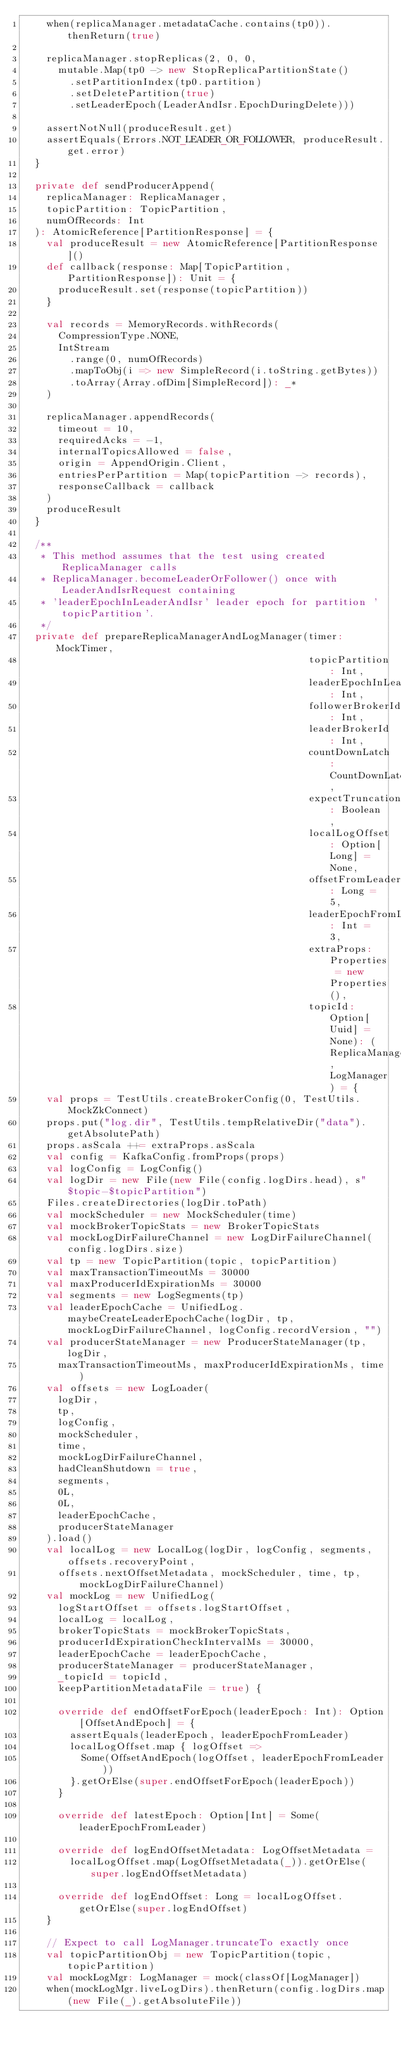Convert code to text. <code><loc_0><loc_0><loc_500><loc_500><_Scala_>    when(replicaManager.metadataCache.contains(tp0)).thenReturn(true)

    replicaManager.stopReplicas(2, 0, 0,
      mutable.Map(tp0 -> new StopReplicaPartitionState()
        .setPartitionIndex(tp0.partition)
        .setDeletePartition(true)
        .setLeaderEpoch(LeaderAndIsr.EpochDuringDelete)))

    assertNotNull(produceResult.get)
    assertEquals(Errors.NOT_LEADER_OR_FOLLOWER, produceResult.get.error)
  }

  private def sendProducerAppend(
    replicaManager: ReplicaManager,
    topicPartition: TopicPartition,
    numOfRecords: Int
  ): AtomicReference[PartitionResponse] = {
    val produceResult = new AtomicReference[PartitionResponse]()
    def callback(response: Map[TopicPartition, PartitionResponse]): Unit = {
      produceResult.set(response(topicPartition))
    }

    val records = MemoryRecords.withRecords(
      CompressionType.NONE,
      IntStream
        .range(0, numOfRecords)
        .mapToObj(i => new SimpleRecord(i.toString.getBytes))
        .toArray(Array.ofDim[SimpleRecord]): _*
    )

    replicaManager.appendRecords(
      timeout = 10,
      requiredAcks = -1,
      internalTopicsAllowed = false,
      origin = AppendOrigin.Client,
      entriesPerPartition = Map(topicPartition -> records),
      responseCallback = callback
    )
    produceResult
  }

  /**
   * This method assumes that the test using created ReplicaManager calls
   * ReplicaManager.becomeLeaderOrFollower() once with LeaderAndIsrRequest containing
   * 'leaderEpochInLeaderAndIsr' leader epoch for partition 'topicPartition'.
   */
  private def prepareReplicaManagerAndLogManager(timer: MockTimer,
                                                 topicPartition: Int,
                                                 leaderEpochInLeaderAndIsr: Int,
                                                 followerBrokerId: Int,
                                                 leaderBrokerId: Int,
                                                 countDownLatch: CountDownLatch,
                                                 expectTruncation: Boolean,
                                                 localLogOffset: Option[Long] = None,
                                                 offsetFromLeader: Long = 5,
                                                 leaderEpochFromLeader: Int = 3,
                                                 extraProps: Properties = new Properties(),
                                                 topicId: Option[Uuid] = None): (ReplicaManager, LogManager) = {
    val props = TestUtils.createBrokerConfig(0, TestUtils.MockZkConnect)
    props.put("log.dir", TestUtils.tempRelativeDir("data").getAbsolutePath)
    props.asScala ++= extraProps.asScala
    val config = KafkaConfig.fromProps(props)
    val logConfig = LogConfig()
    val logDir = new File(new File(config.logDirs.head), s"$topic-$topicPartition")
    Files.createDirectories(logDir.toPath)
    val mockScheduler = new MockScheduler(time)
    val mockBrokerTopicStats = new BrokerTopicStats
    val mockLogDirFailureChannel = new LogDirFailureChannel(config.logDirs.size)
    val tp = new TopicPartition(topic, topicPartition)
    val maxTransactionTimeoutMs = 30000
    val maxProducerIdExpirationMs = 30000
    val segments = new LogSegments(tp)
    val leaderEpochCache = UnifiedLog.maybeCreateLeaderEpochCache(logDir, tp, mockLogDirFailureChannel, logConfig.recordVersion, "")
    val producerStateManager = new ProducerStateManager(tp, logDir,
      maxTransactionTimeoutMs, maxProducerIdExpirationMs, time)
    val offsets = new LogLoader(
      logDir,
      tp,
      logConfig,
      mockScheduler,
      time,
      mockLogDirFailureChannel,
      hadCleanShutdown = true,
      segments,
      0L,
      0L,
      leaderEpochCache,
      producerStateManager
    ).load()
    val localLog = new LocalLog(logDir, logConfig, segments, offsets.recoveryPoint,
      offsets.nextOffsetMetadata, mockScheduler, time, tp, mockLogDirFailureChannel)
    val mockLog = new UnifiedLog(
      logStartOffset = offsets.logStartOffset,
      localLog = localLog,
      brokerTopicStats = mockBrokerTopicStats,
      producerIdExpirationCheckIntervalMs = 30000,
      leaderEpochCache = leaderEpochCache,
      producerStateManager = producerStateManager,
      _topicId = topicId,
      keepPartitionMetadataFile = true) {

      override def endOffsetForEpoch(leaderEpoch: Int): Option[OffsetAndEpoch] = {
        assertEquals(leaderEpoch, leaderEpochFromLeader)
        localLogOffset.map { logOffset =>
          Some(OffsetAndEpoch(logOffset, leaderEpochFromLeader))
        }.getOrElse(super.endOffsetForEpoch(leaderEpoch))
      }

      override def latestEpoch: Option[Int] = Some(leaderEpochFromLeader)

      override def logEndOffsetMetadata: LogOffsetMetadata =
        localLogOffset.map(LogOffsetMetadata(_)).getOrElse(super.logEndOffsetMetadata)

      override def logEndOffset: Long = localLogOffset.getOrElse(super.logEndOffset)
    }

    // Expect to call LogManager.truncateTo exactly once
    val topicPartitionObj = new TopicPartition(topic, topicPartition)
    val mockLogMgr: LogManager = mock(classOf[LogManager])
    when(mockLogMgr.liveLogDirs).thenReturn(config.logDirs.map(new File(_).getAbsoluteFile))</code> 